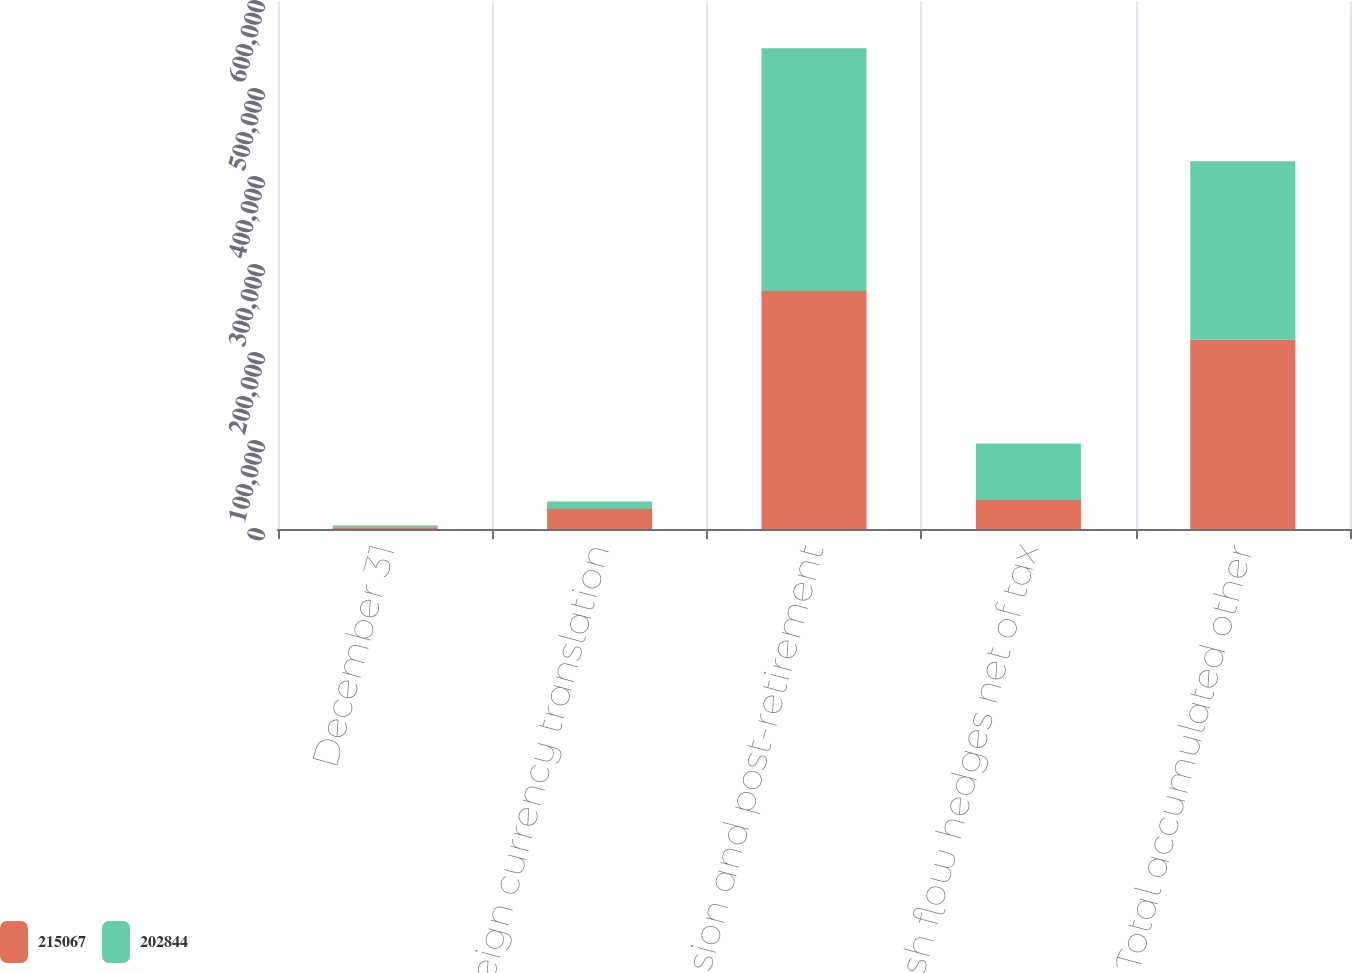Convert chart. <chart><loc_0><loc_0><loc_500><loc_500><stacked_bar_chart><ecel><fcel>December 31<fcel>Foreign currency translation<fcel>Pension and post-retirement<fcel>Cash flow hedges net of tax<fcel>Total accumulated other<nl><fcel>215067<fcel>2010<fcel>22672<fcel>270580<fcel>32841<fcel>215067<nl><fcel>202844<fcel>2009<fcel>8549<fcel>275710<fcel>64317<fcel>202844<nl></chart> 